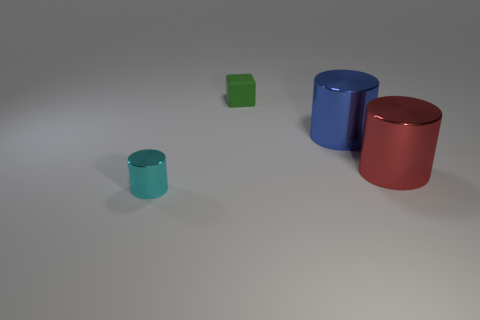Is the shape of the large metal thing that is on the right side of the blue thing the same as the thing that is on the left side of the rubber thing?
Make the answer very short. Yes. Is there any other thing that has the same shape as the large red thing?
Provide a succinct answer. Yes. What is the shape of the blue thing that is made of the same material as the cyan cylinder?
Ensure brevity in your answer.  Cylinder. Are there the same number of tiny cylinders that are on the left side of the large red cylinder and gray shiny cylinders?
Ensure brevity in your answer.  No. Do the tiny thing that is to the right of the cyan shiny object and the small thing in front of the rubber cube have the same material?
Make the answer very short. No. There is a small thing that is on the right side of the small thing that is to the left of the tiny block; what shape is it?
Offer a terse response. Cube. There is a small thing that is the same material as the large blue thing; what is its color?
Your answer should be compact. Cyan. Do the small rubber cube and the tiny metallic object have the same color?
Give a very brief answer. No. What is the shape of the other rubber thing that is the same size as the cyan object?
Offer a very short reply. Cube. The blue cylinder is what size?
Your answer should be very brief. Large. 